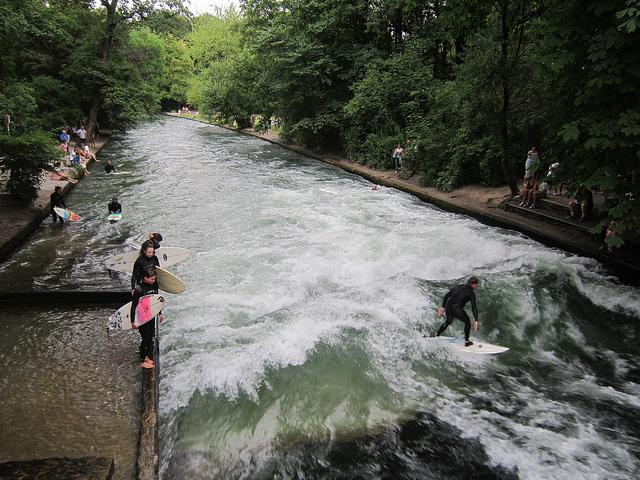How many people are standing on the river bank?
Keep it brief. 7. What color is the surfboard on the left?
Keep it brief. White. Is it safe to jump in?
Concise answer only. No. What is white on the water?
Be succinct. Waves. 